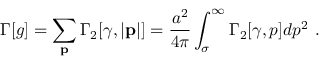Convert formula to latex. <formula><loc_0><loc_0><loc_500><loc_500>\Gamma [ g ] = \sum _ { p } \Gamma _ { 2 } [ \gamma , | { p } | ] = { \frac { a ^ { 2 } } { 4 \pi } } \int _ { \sigma } ^ { \infty } \Gamma _ { 2 } [ \gamma , p ] d p ^ { 2 } .</formula> 